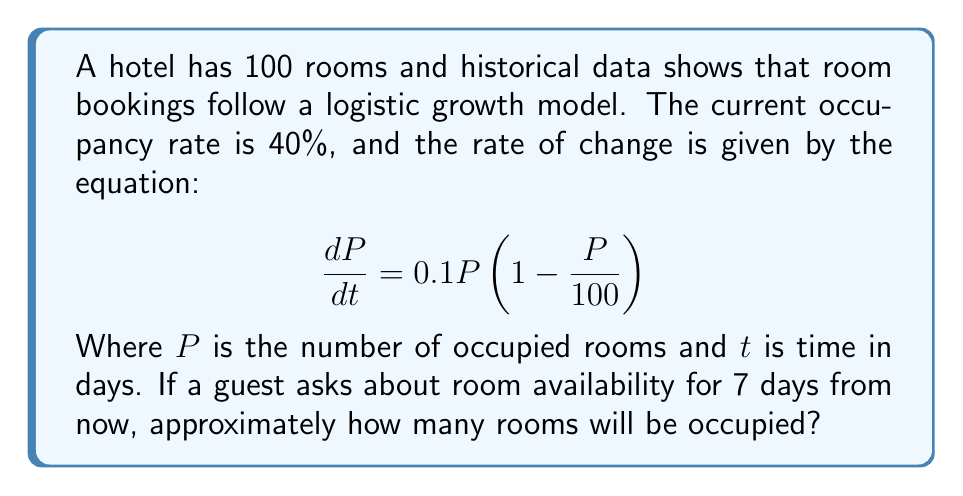Teach me how to tackle this problem. To solve this problem, we need to use the logistic growth model and numerical approximation:

1. Initial condition: $P_0 = 40$ rooms (40% of 100 rooms)

2. The logistic equation is:
   $$\frac{dP}{dt} = 0.1P(1 - \frac{P}{100})$$

3. We can use Euler's method for numerical approximation:
   $$P_{n+1} = P_n + \frac{dP}{dt} \Delta t$$

4. Let's use a step size of $\Delta t = 1$ day for 7 iterations:

   Day 0: $P_0 = 40$
   Day 1: $P_1 = 40 + 0.1 \cdot 40 \cdot (1 - \frac{40}{100}) \cdot 1 = 42.4$
   Day 2: $P_2 = 42.4 + 0.1 \cdot 42.4 \cdot (1 - \frac{42.4}{100}) \cdot 1 = 44.72$
   Day 3: $P_3 = 44.72 + 0.1 \cdot 44.72 \cdot (1 - \frac{44.72}{100}) \cdot 1 = 46.95$
   Day 4: $P_4 = 46.95 + 0.1 \cdot 46.95 \cdot (1 - \frac{46.95}{100}) \cdot 1 = 49.09$
   Day 5: $P_5 = 49.09 + 0.1 \cdot 49.09 \cdot (1 - \frac{49.09}{100}) \cdot 1 = 51.13$
   Day 6: $P_6 = 51.13 + 0.1 \cdot 51.13 \cdot (1 - \frac{51.13}{100}) \cdot 1 = 53.06$
   Day 7: $P_7 = 53.06 + 0.1 \cdot 53.06 \cdot (1 - \frac{53.06}{100}) \cdot 1 = 54.88$

5. Rounding to the nearest whole number, we get 55 rooms occupied after 7 days.
Answer: 55 rooms 